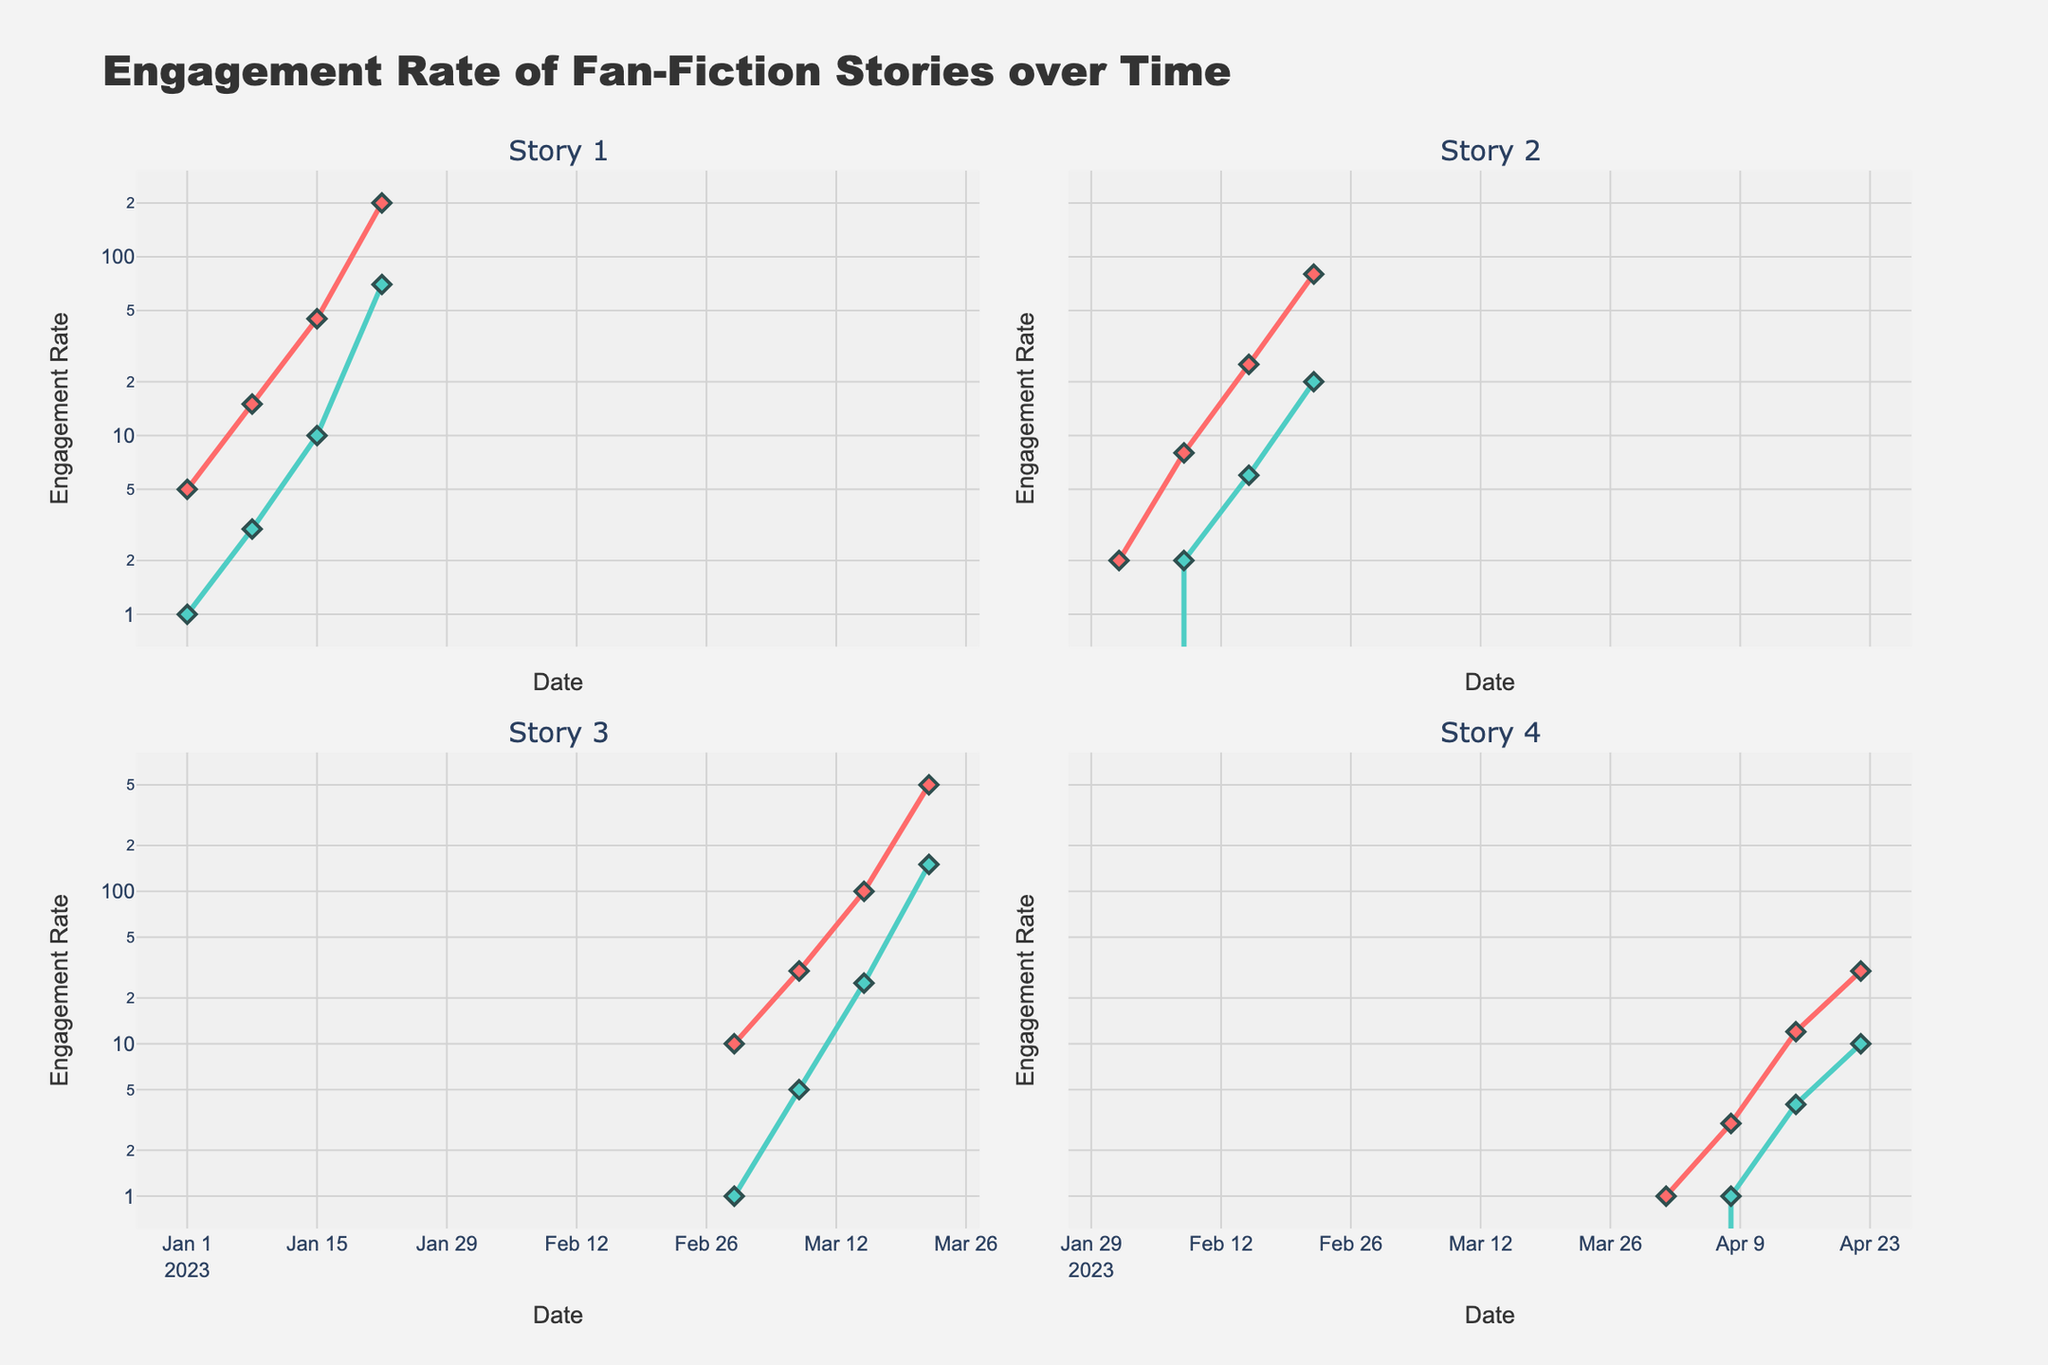What is the title of the graph? The title is displayed at the top of the graph. It reads "Engagement Rate of Fan-Fiction Stories over Time."
Answer: Engagement Rate of Fan-Fiction Stories over Time How many story panels are displayed in the figure? There are separate subplots for each story, and the subplot titles indicate four stories, labeled Story 1 through Story 4.
Answer: Four Which engagement type uses the red color for its lines and markers? The legend or the color consistency across subplots can indicate which engagement type uses specific colors. Red represents "Likes" across all stories.
Answer: Likes What is the total engagement rate (Likes + Comments) for Story 1 on 2023-01-22? Identify the engagement rates for Likes and Comments on 2023-01-22 for Story 1 from the subplot, then sum them up: 200 (Likes) + 70 (Comments) = 270.
Answer: 270 Which story showed the most rapid increase in Likes over the observed period? By comparing slopes of the lines representing Likes across the subplots, Story 3 shows the steepest increase from 10 to 500.
Answer: Story 3 What is the engagement rate difference between Likes and Comments for Story 2 on 2023-02-22? For Story 2 on 2023-02-22, subtract the Comment engagement rate from the Like engagement rate: 80 - 20 = 60.
Answer: 60 How do the engagement rates of Comments for Story 4 on 2023-04-08 compare to those on 2023-04-15? Check the Comment engagement rates for Story 4 on the two dates from the subplot, then compare them: 1 (on 2023-04-08) versus 4 (on 2023-04-15).
Answer: Less on 2023-04-08 What is the average engagement rate of Likes for Story 3 across all observed dates? Identify the engagement rates for Likes on all dates for Story 3, then calculate the average: (10 + 30 + 100 + 500)/4 = 160.
Answer: 160 Which date saw the highest engagement rate for Comments in Story 3? In Story 3's subplot, the highest Comment engagement rate is observed on 2023-03-22.
Answer: 2023-03-22 In Story 1, how does the trend in engagement rates for Likes compare to that for Comments over time? Examine the slopes and patterns of both lines for Story 1's Likes and Comments. It shows that both engagement rates increase over time, but Likes increase at a much steeper rate.
Answer: Likes increase faster 